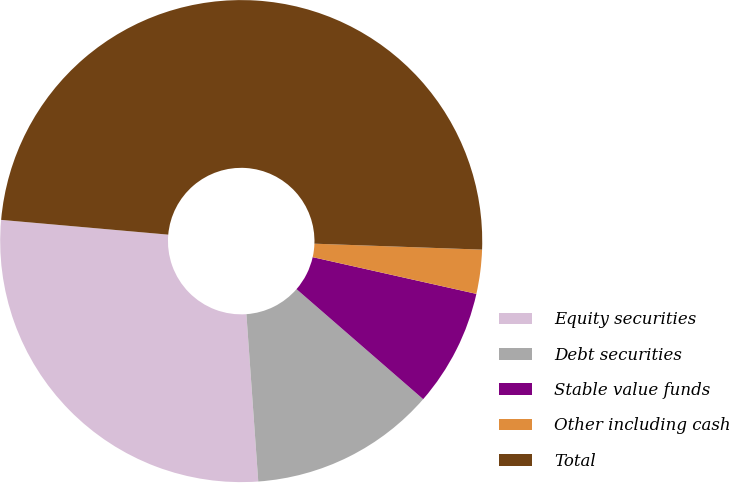Convert chart to OTSL. <chart><loc_0><loc_0><loc_500><loc_500><pie_chart><fcel>Equity securities<fcel>Debt securities<fcel>Stable value funds<fcel>Other including cash<fcel>Total<nl><fcel>27.53%<fcel>12.49%<fcel>7.87%<fcel>2.95%<fcel>49.16%<nl></chart> 